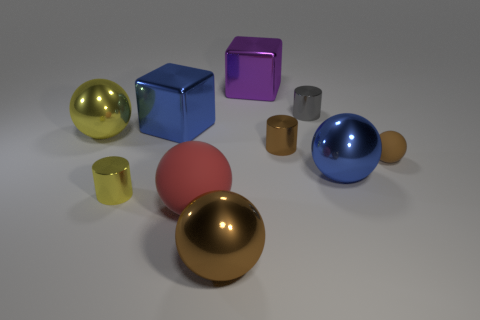Is the number of brown metal things to the left of the tiny gray metallic object the same as the number of purple shiny cubes?
Make the answer very short. No. How many other things are the same size as the red rubber ball?
Make the answer very short. 5. Is the sphere that is in front of the large matte ball made of the same material as the blue object in front of the big yellow object?
Give a very brief answer. Yes. What is the size of the blue shiny object in front of the yellow thing behind the tiny yellow shiny thing?
Make the answer very short. Large. Is there a cylinder that has the same color as the small matte object?
Provide a short and direct response. Yes. Does the metal cylinder that is behind the big yellow ball have the same color as the large metal block that is on the left side of the large purple shiny cube?
Your response must be concise. No. What shape is the small brown shiny object?
Provide a short and direct response. Cylinder. There is a big yellow thing; how many blue balls are in front of it?
Provide a short and direct response. 1. What number of large yellow objects are made of the same material as the blue sphere?
Offer a terse response. 1. Does the big blue thing on the left side of the brown metallic ball have the same material as the tiny sphere?
Make the answer very short. No. 